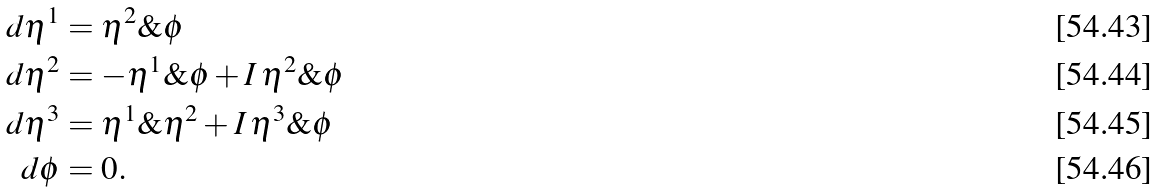Convert formula to latex. <formula><loc_0><loc_0><loc_500><loc_500>d \eta ^ { 1 } & = \eta ^ { 2 } \& \phi \\ d \eta ^ { 2 } & = - \eta ^ { 1 } \& \phi + I \, \eta ^ { 2 } \& \phi \\ d \eta ^ { 3 } & = \eta ^ { 1 } \& \eta ^ { 2 } + I \, \eta ^ { 3 } \& \phi \\ d \phi & = 0 .</formula> 